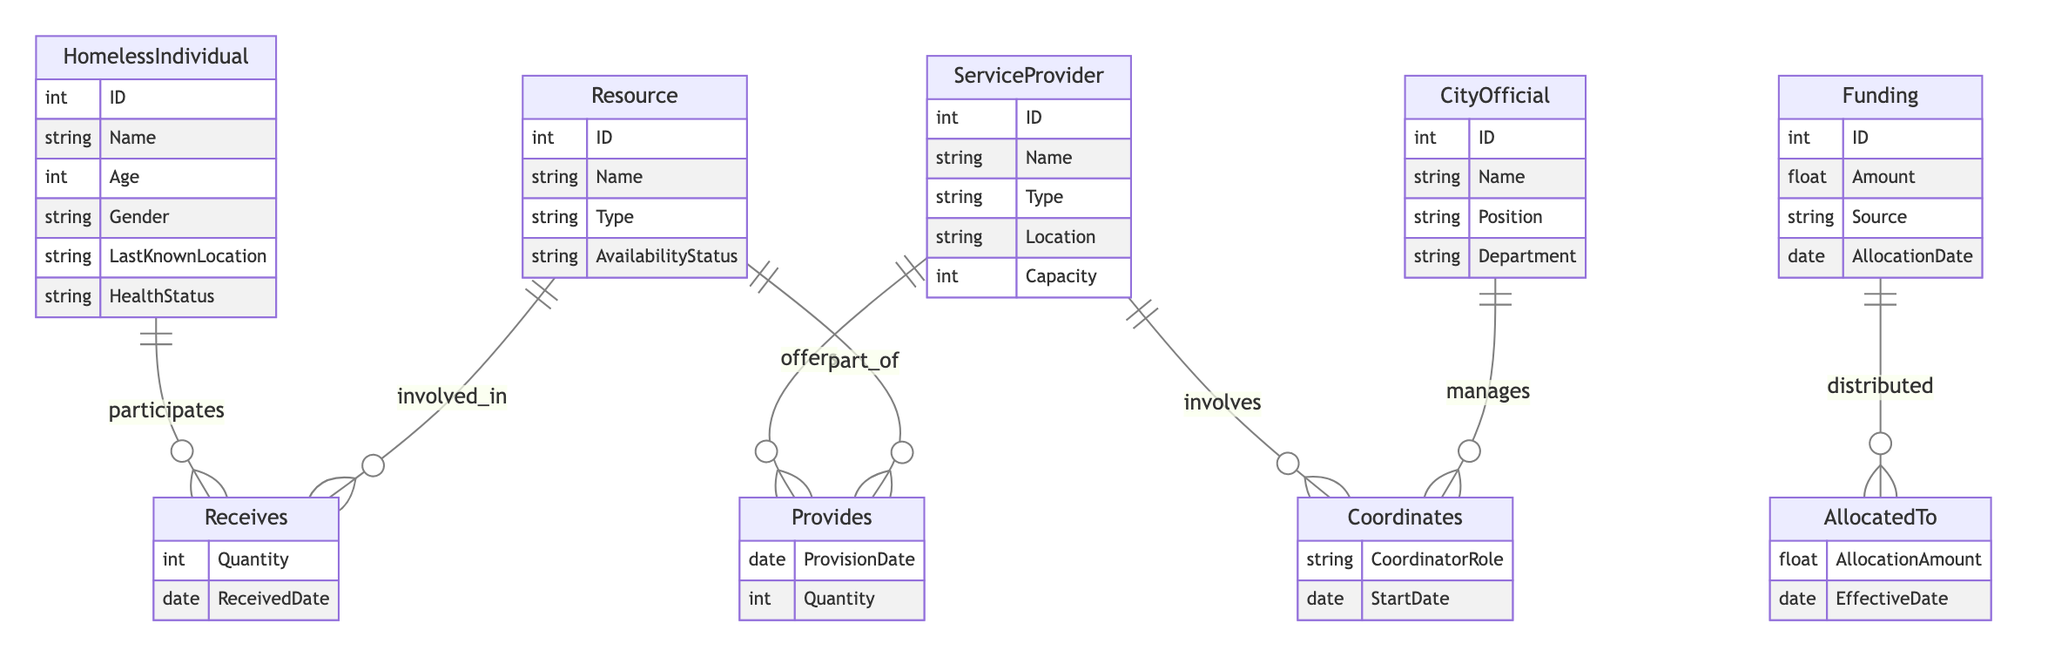What are the attributes of a HomelessIndividual? The attributes of the HomelessIndividual entity are ID, Name, Age, Gender, LastKnownLocation, and HealthStatus. These attributes provide fundamental personal information about each homeless individual.
Answer: ID, Name, Age, Gender, LastKnownLocation, HealthStatus How many relationships connect ServiceProvider to other entities? The ServiceProvider entity is connected to three relationships: Receives, Coordinates, and Provides. Each of these relationships involves another entity, indicating different interactions.
Answer: Three What attribute connects CityOfficial to ServiceProvider? The attribute that connects CityOfficial to ServiceProvider through the Coordinates relationship is CoordinatorRole. This attribute indicates the role of the city official in managing the service provider’s activities.
Answer: CoordinatorRole How many resources can a ServiceProvider provide? The Capacity attribute in the ServiceProvider entity represents how many resources it can provide. This is an integer value indicating the maximum amount a provider can handle.
Answer: Capacity What is the relationship between Funding and ServiceProvider? The relationship between Funding and ServiceProvider is defined as AllocatedTo, which indicates that funding is distributed to service providers for their operations.
Answer: AllocatedTo Which entity receives resources? The entity that receives resources is HomelessIndividual through the Receives relationship. This describes the interaction where homeless individuals obtain the necessary resources for support.
Answer: HomelessIndividual What details are included in the Provides relationship? The Provides relationship includes the attributes ProvisionDate and Quantity. This indicates when resources are provided and the number of resources provided.
Answer: ProvisionDate, Quantity What defines the AvailabilityStatus in Resource? AvailabilityStatus describes whether a resource is currently available or not, providing crucial information about resource accessibility for homeless individuals.
Answer: AvailabilityStatus How is the amount of funding allocated to ServiceProvider determined? The funding allocated to ServiceProvider is specified by the AllocationAmount attribute in the AllocatedTo relationship, which details the specific amount of funds given to support the provider's services.
Answer: AllocationAmount 